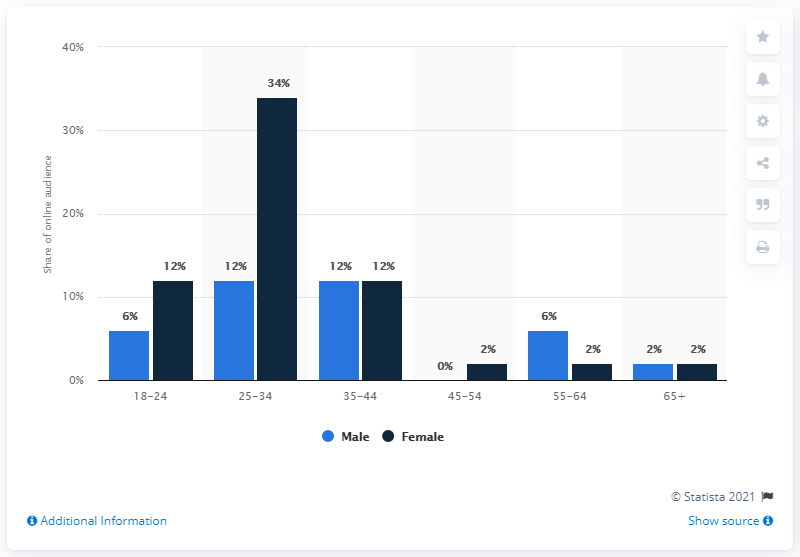Draw attention to some important aspects in this diagram. The blue bar disappears in the 45-54 age group. The age group with the greatest disparity between men and women is 25-34. 